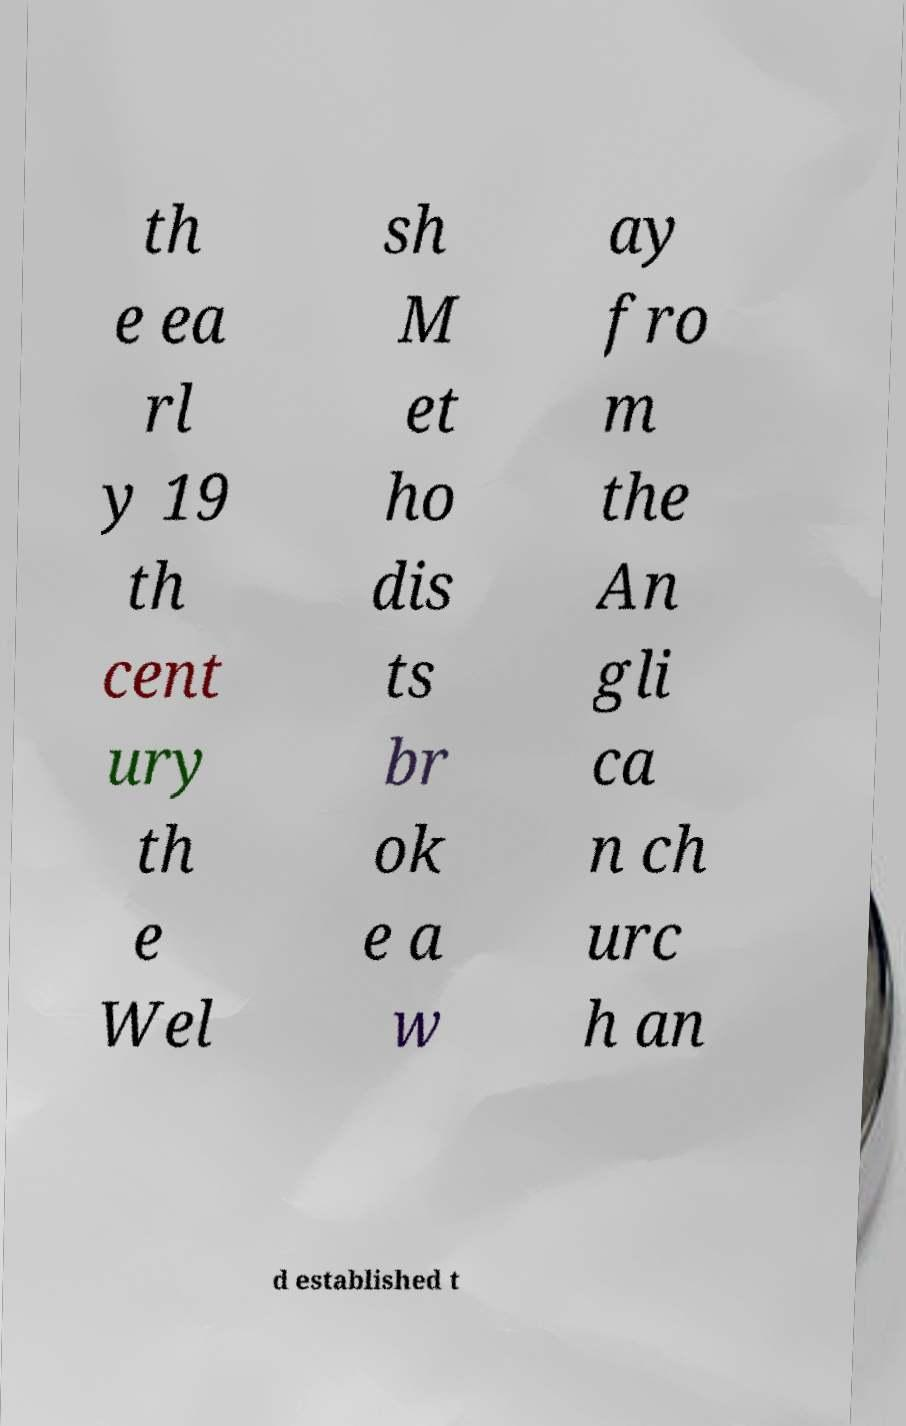Please read and relay the text visible in this image. What does it say? th e ea rl y 19 th cent ury th e Wel sh M et ho dis ts br ok e a w ay fro m the An gli ca n ch urc h an d established t 